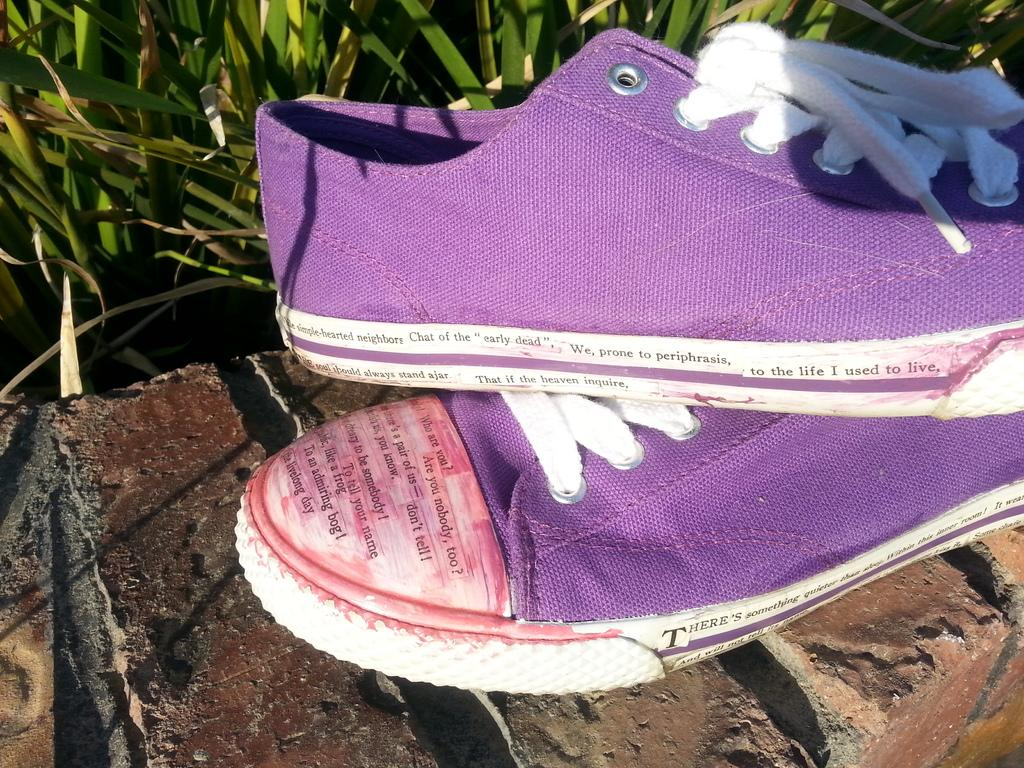What color is the shoe that is visible in the image? The shoe is purple. Where is the shoe located in the image? The shoe is on a wall. What type of vegetation can be seen in the image? There is grass visible in the image. What type of pencil can be seen in the image? There is no pencil present in the image. How is the ice used in the image? There is no ice present in the image. 